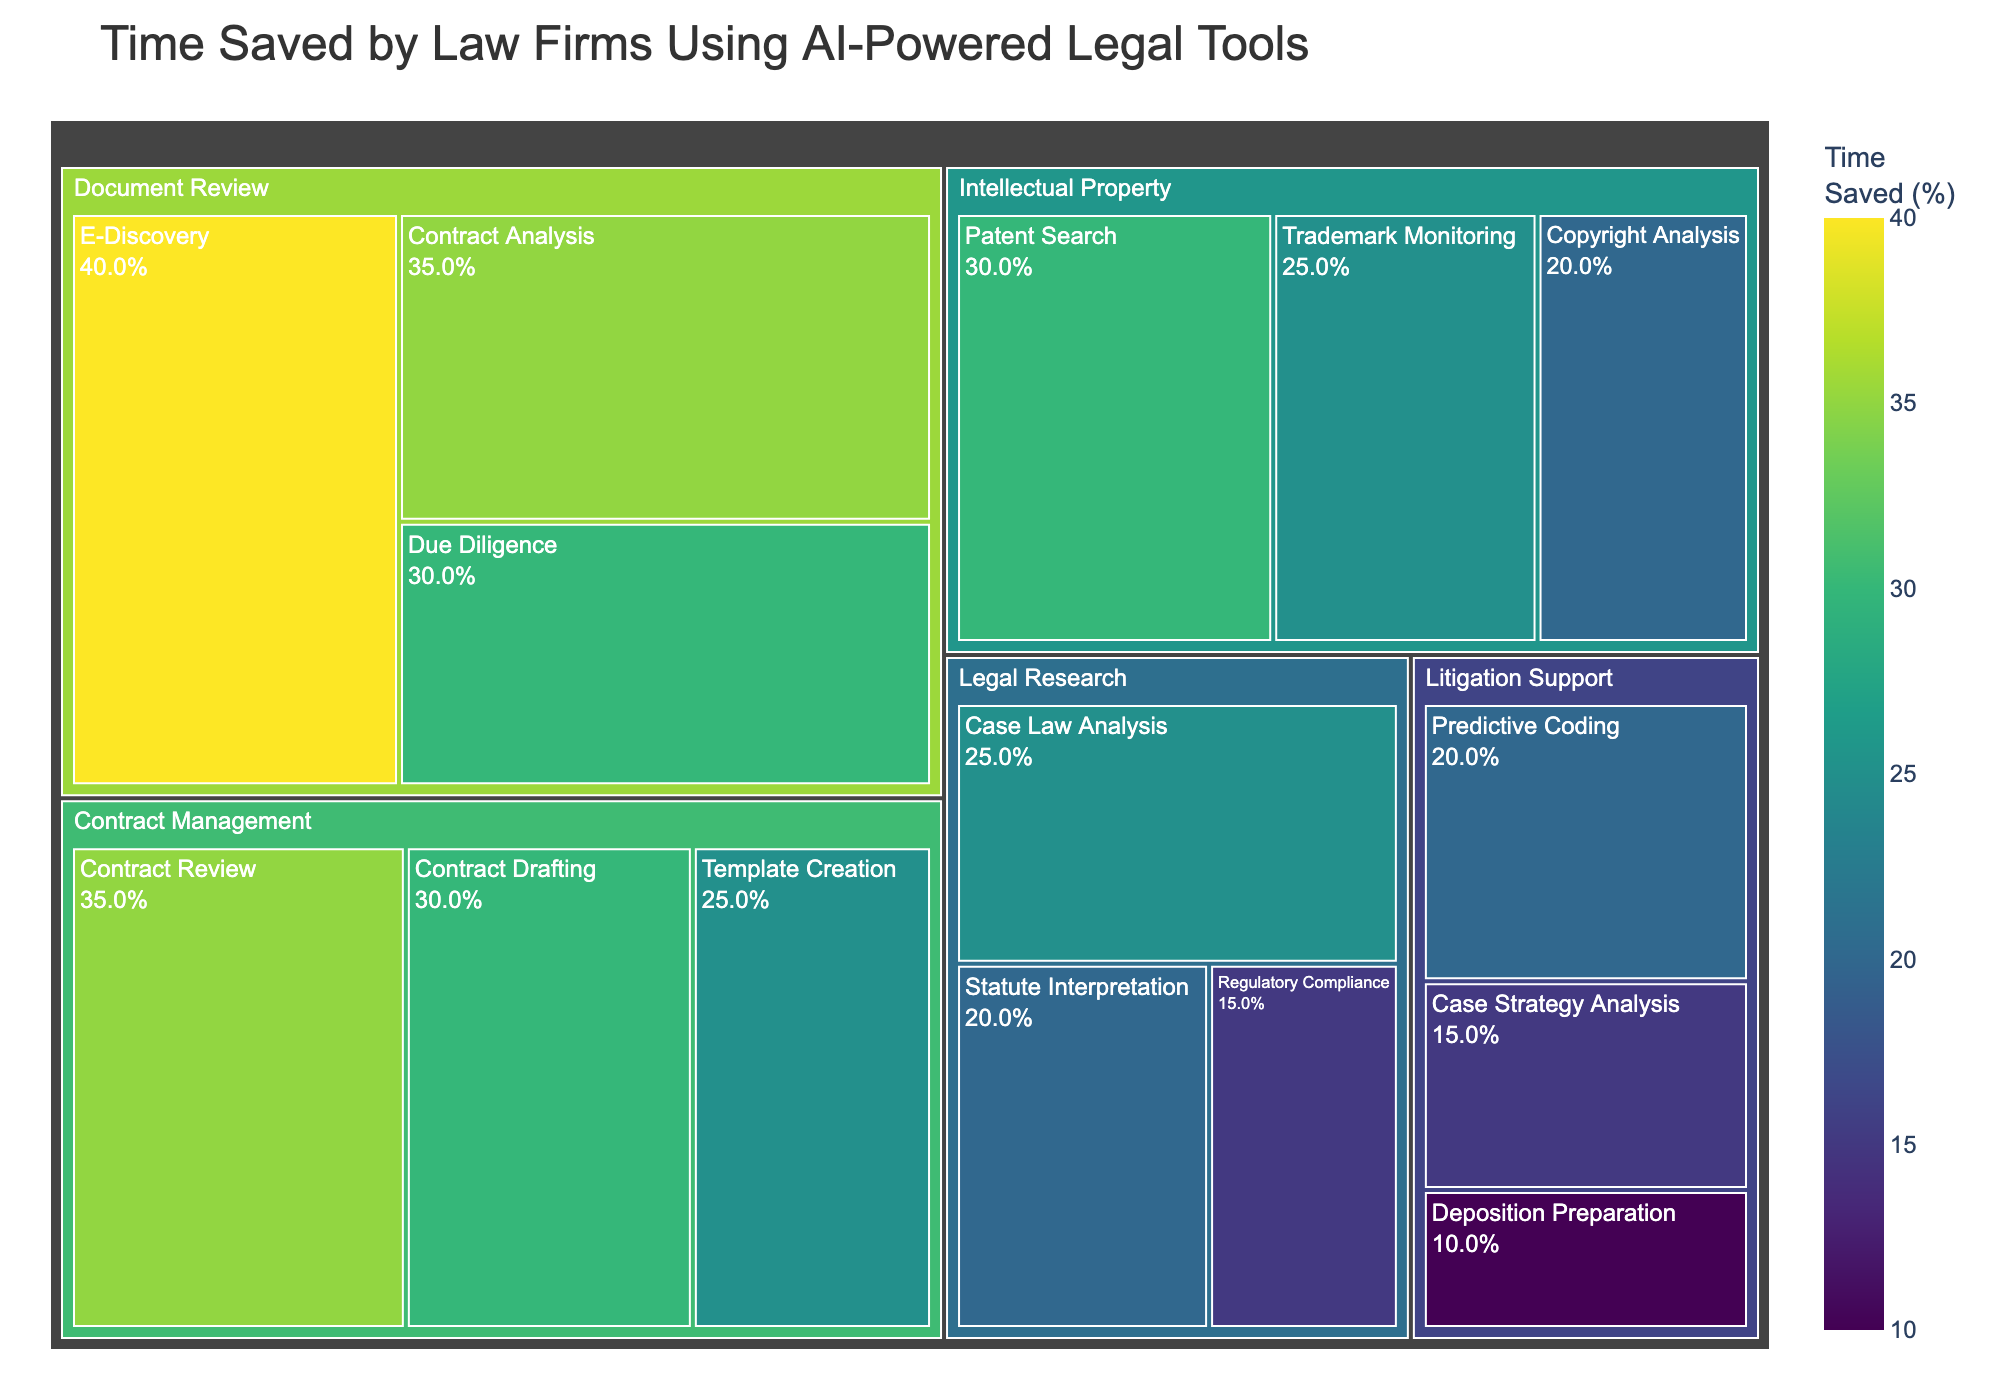What is the title of the treemap? The title of the treemap is displayed at the top of the figure, providing a description of the data being visualized.
Answer: Time Saved by Law Firms Using AI-Powered Legal Tools Which subcategory in the 'Document Review' category saves the most time? Look at the 'Document Review' section in the treemap and identify the subcategory with the highest percentage.
Answer: E-Discovery What is the total percentage of time saved in the 'Legal Research' category? Add the time saved percentages of all the subcategories under 'Legal Research': Case Law Analysis (25%) + Statute Interpretation (20%) + Regulatory Compliance (15%).
Answer: 60% Which category has the subcategory with the least time saved, and what is that percentage? Identify the subcategory with the smallest percentage in each category and find the lowest one. 'Litigation Support' has 'Deposition Preparation' with 10%.
Answer: Litigation Support, 10% Compare the time saved between 'Contract Review' and 'Contract Drafting' under 'Contract Management'. Which one is higher and by how much? Subtract the time saved percentage of 'Contract Drafting' from 'Contract Review'. 'Contract Review' saves 35% and 'Contract Drafting' saves 30%. The difference is 35% - 30% = 5%.
Answer: Contract Review, 5% What is the average time saved percentage across all 'Intellectual Property' subcategories? Sum the percentages of the subcategories under 'Intellectual Property' and divide by the number of subcategories: (Patent Search (30%) + Trademark Monitoring (25%) + Copyright Analysis (20%)) / 3 = 25%.
Answer: 25% Identify the category with the highest overall time saved. Compare the total time saved percentages for each category. 'Document Review' has the highest percentages across its subcategories.
Answer: Document Review How many subcategories save 30% or more time? Count the subcategories whose percentage of time saved is 30% or higher: Contract Analysis (35%), Due Diligence (30%), E-Discovery (40%), Contract Drafting (30%), Contract Review (35%), Patent Search (30%). There are 6 subcategories.
Answer: 6 Which subcategories in 'Litigation Support' save less than 20% time? Identify the subcategories under 'Litigation Support' with time saved percentages below 20%. These are 'Case Strategy Analysis' (15%) and 'Deposition Preparation' (10%).
Answer: Case Strategy Analysis, Deposition Preparation What is the difference in time saved between 'Statute Interpretation' and 'Trademark Monitoring'? Subtract the time saved percentage of 'Statute Interpretation' from 'Trademark Monitoring'. 'Trademark Monitoring' saves 25% and 'Statute Interpretation' saves 20%. The difference is 25% - 20% = 5%.
Answer: 5% 